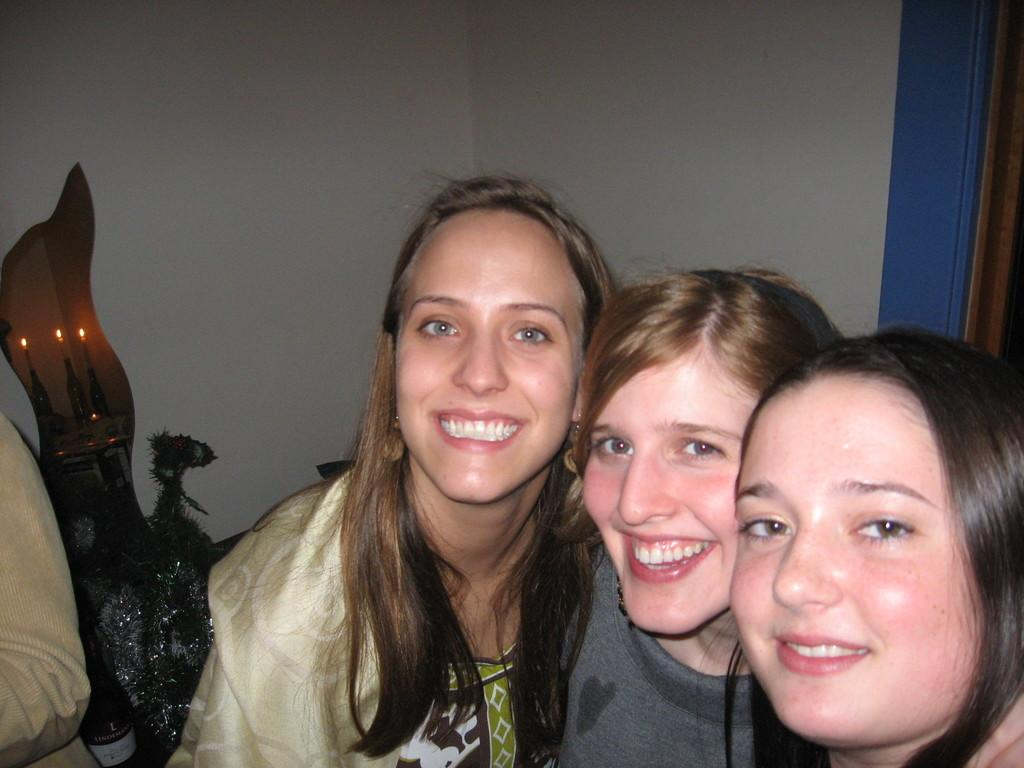How many people are in the image? There are three people in the image. What are the expressions on the faces of the people in the image? The three people are smiling. What are the people in the image doing? The three people are posing for a photo. Can you describe the background of the image? There is a wall in the background of the image. What type of cabbage can be seen growing on the wall in the image? There is no cabbage present in the image; the background features a wall without any plants or vegetables. 